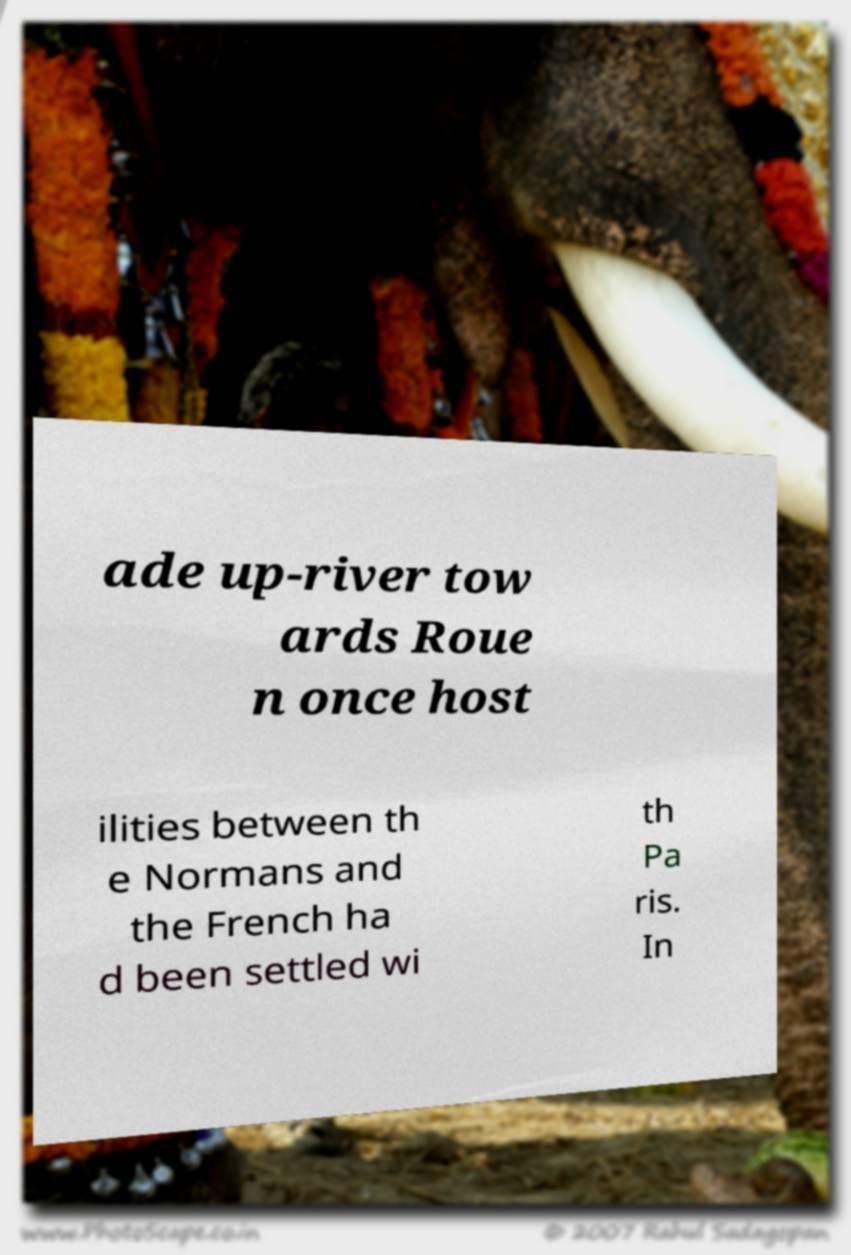There's text embedded in this image that I need extracted. Can you transcribe it verbatim? ade up-river tow ards Roue n once host ilities between th e Normans and the French ha d been settled wi th Pa ris. In 